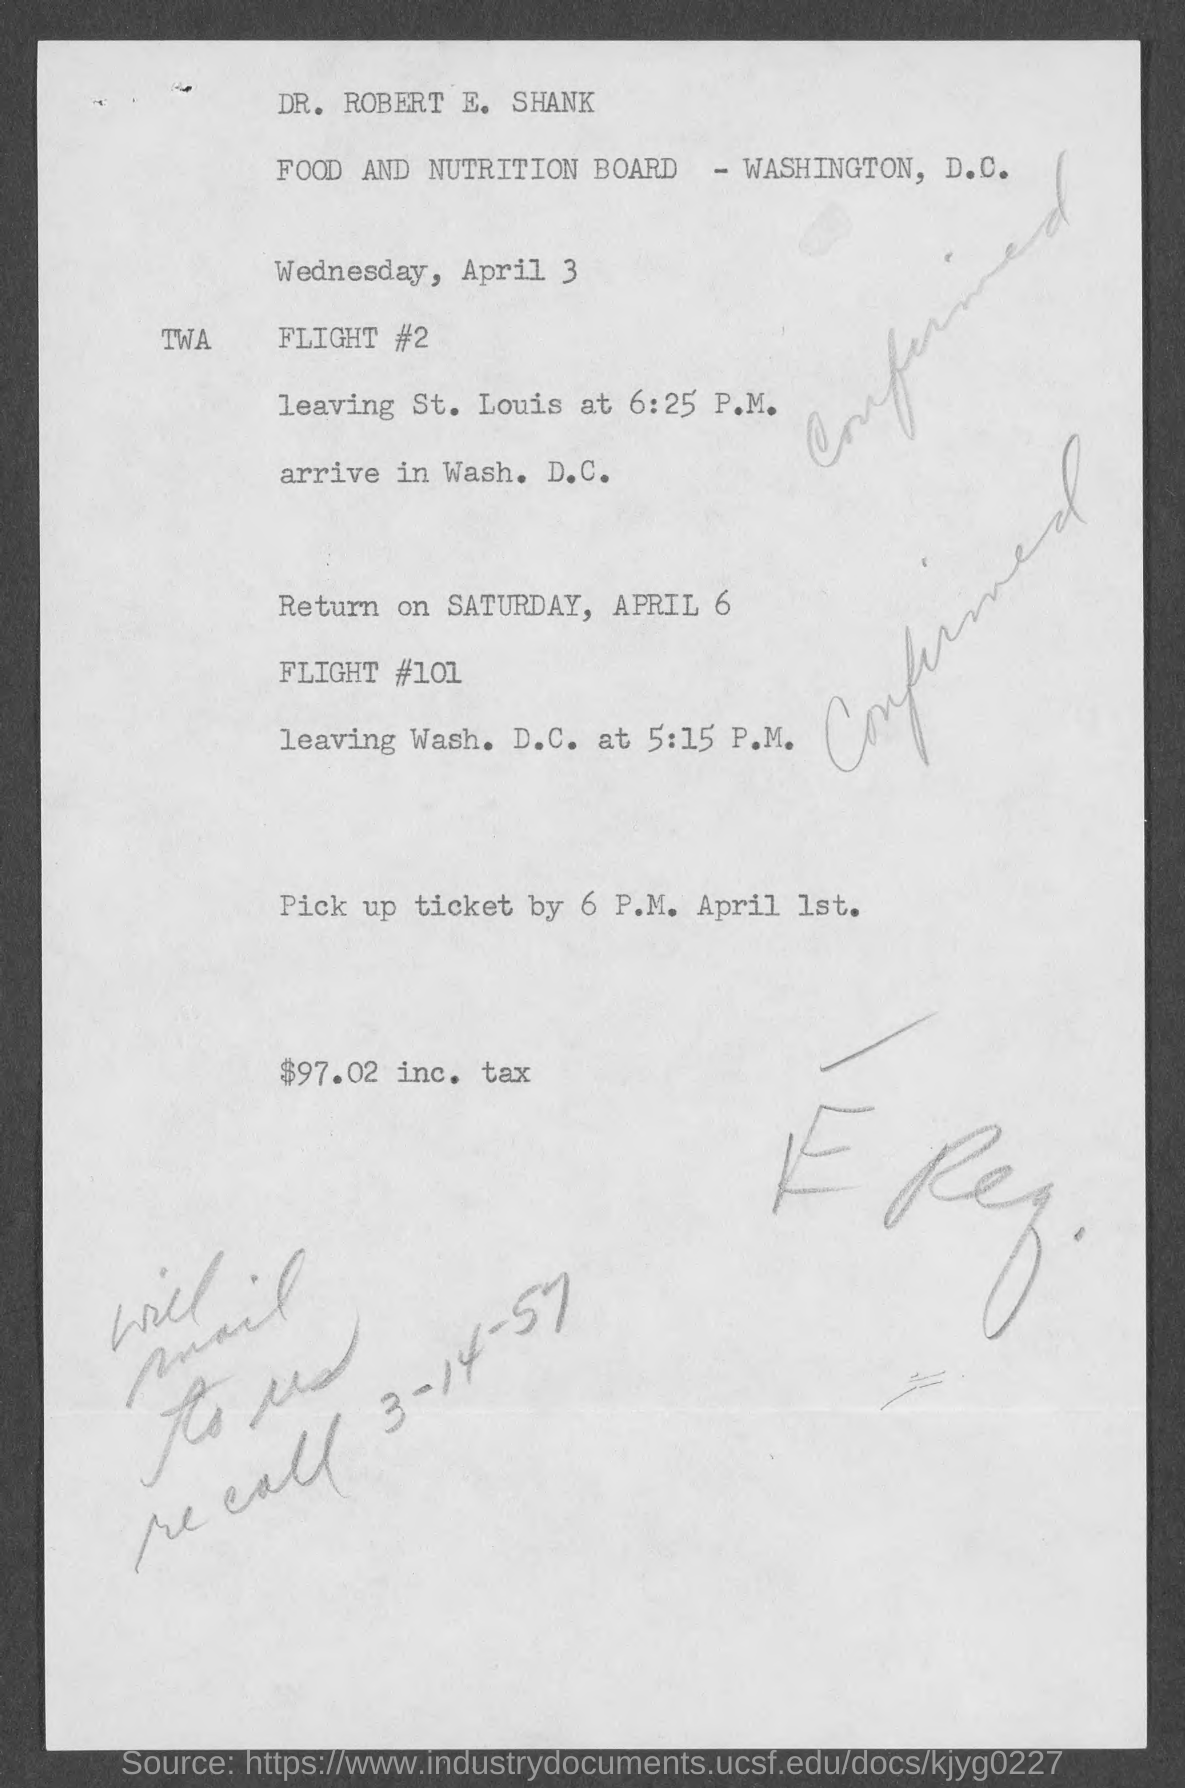At what time will FLIGHT #2 leave St. Louis?
Your answer should be compact. 6:25 P.M. When is the return flight?
Make the answer very short. Saturday, april 6. What is the return flight number?
Keep it short and to the point. 101. What is the amount inc. tax?
Provide a short and direct response. $97.02 inc. tax. 